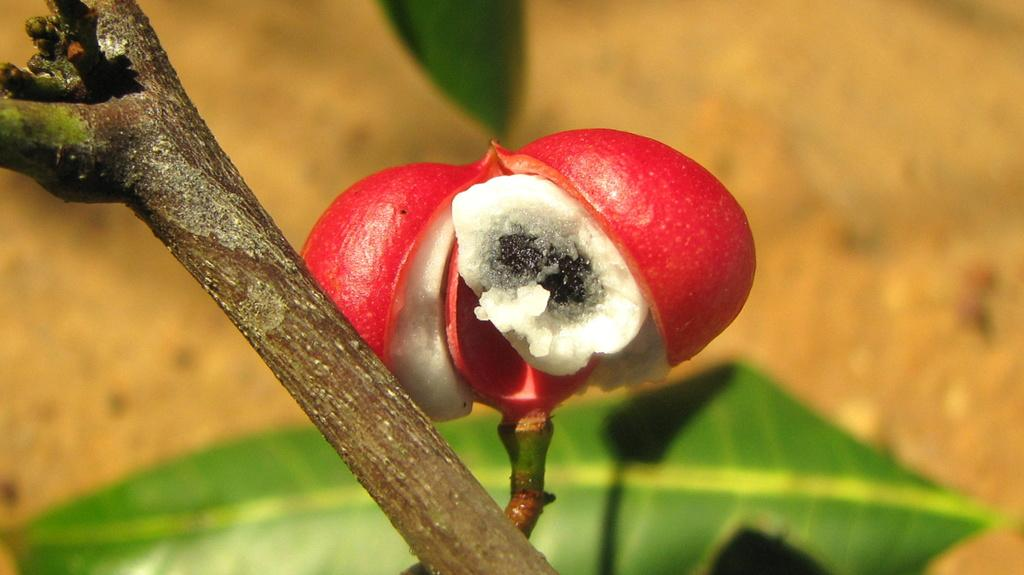What type of object is present at the top of the image? There is a fruit-like object in the image. What can be seen at the bottom of the image? There is a leaf at the bottom of the image. How many trains are visible in the image? There are no trains present in the image. What year is depicted in the image? The image does not depict a specific year. 